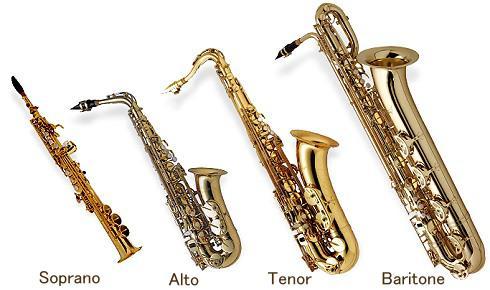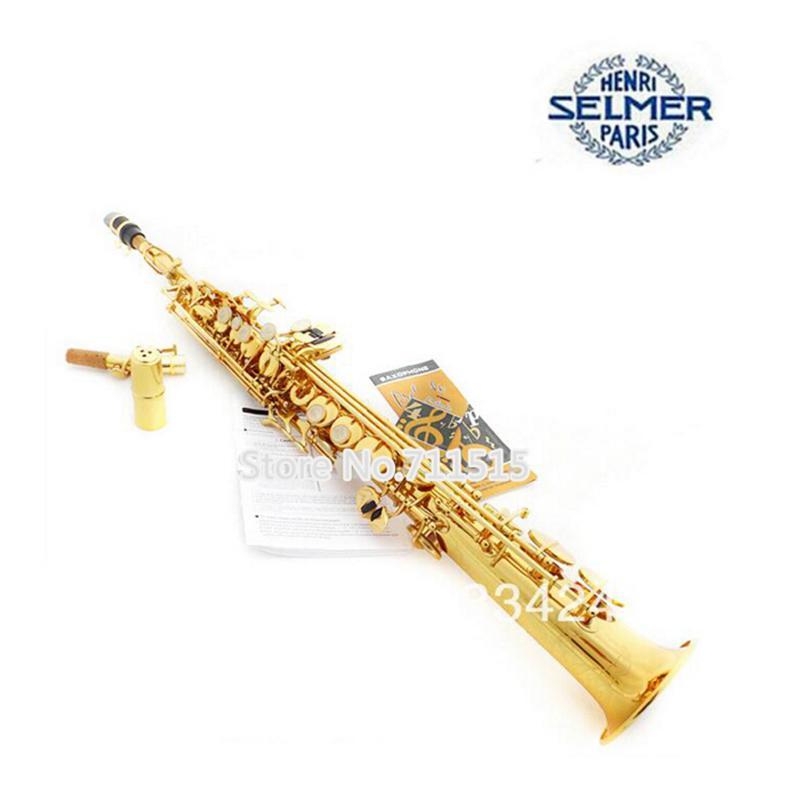The first image is the image on the left, the second image is the image on the right. Examine the images to the left and right. Is the description "One image shows only a straight wind instrument, which is brass colored and does not have an upturned bell." accurate? Answer yes or no. Yes. 